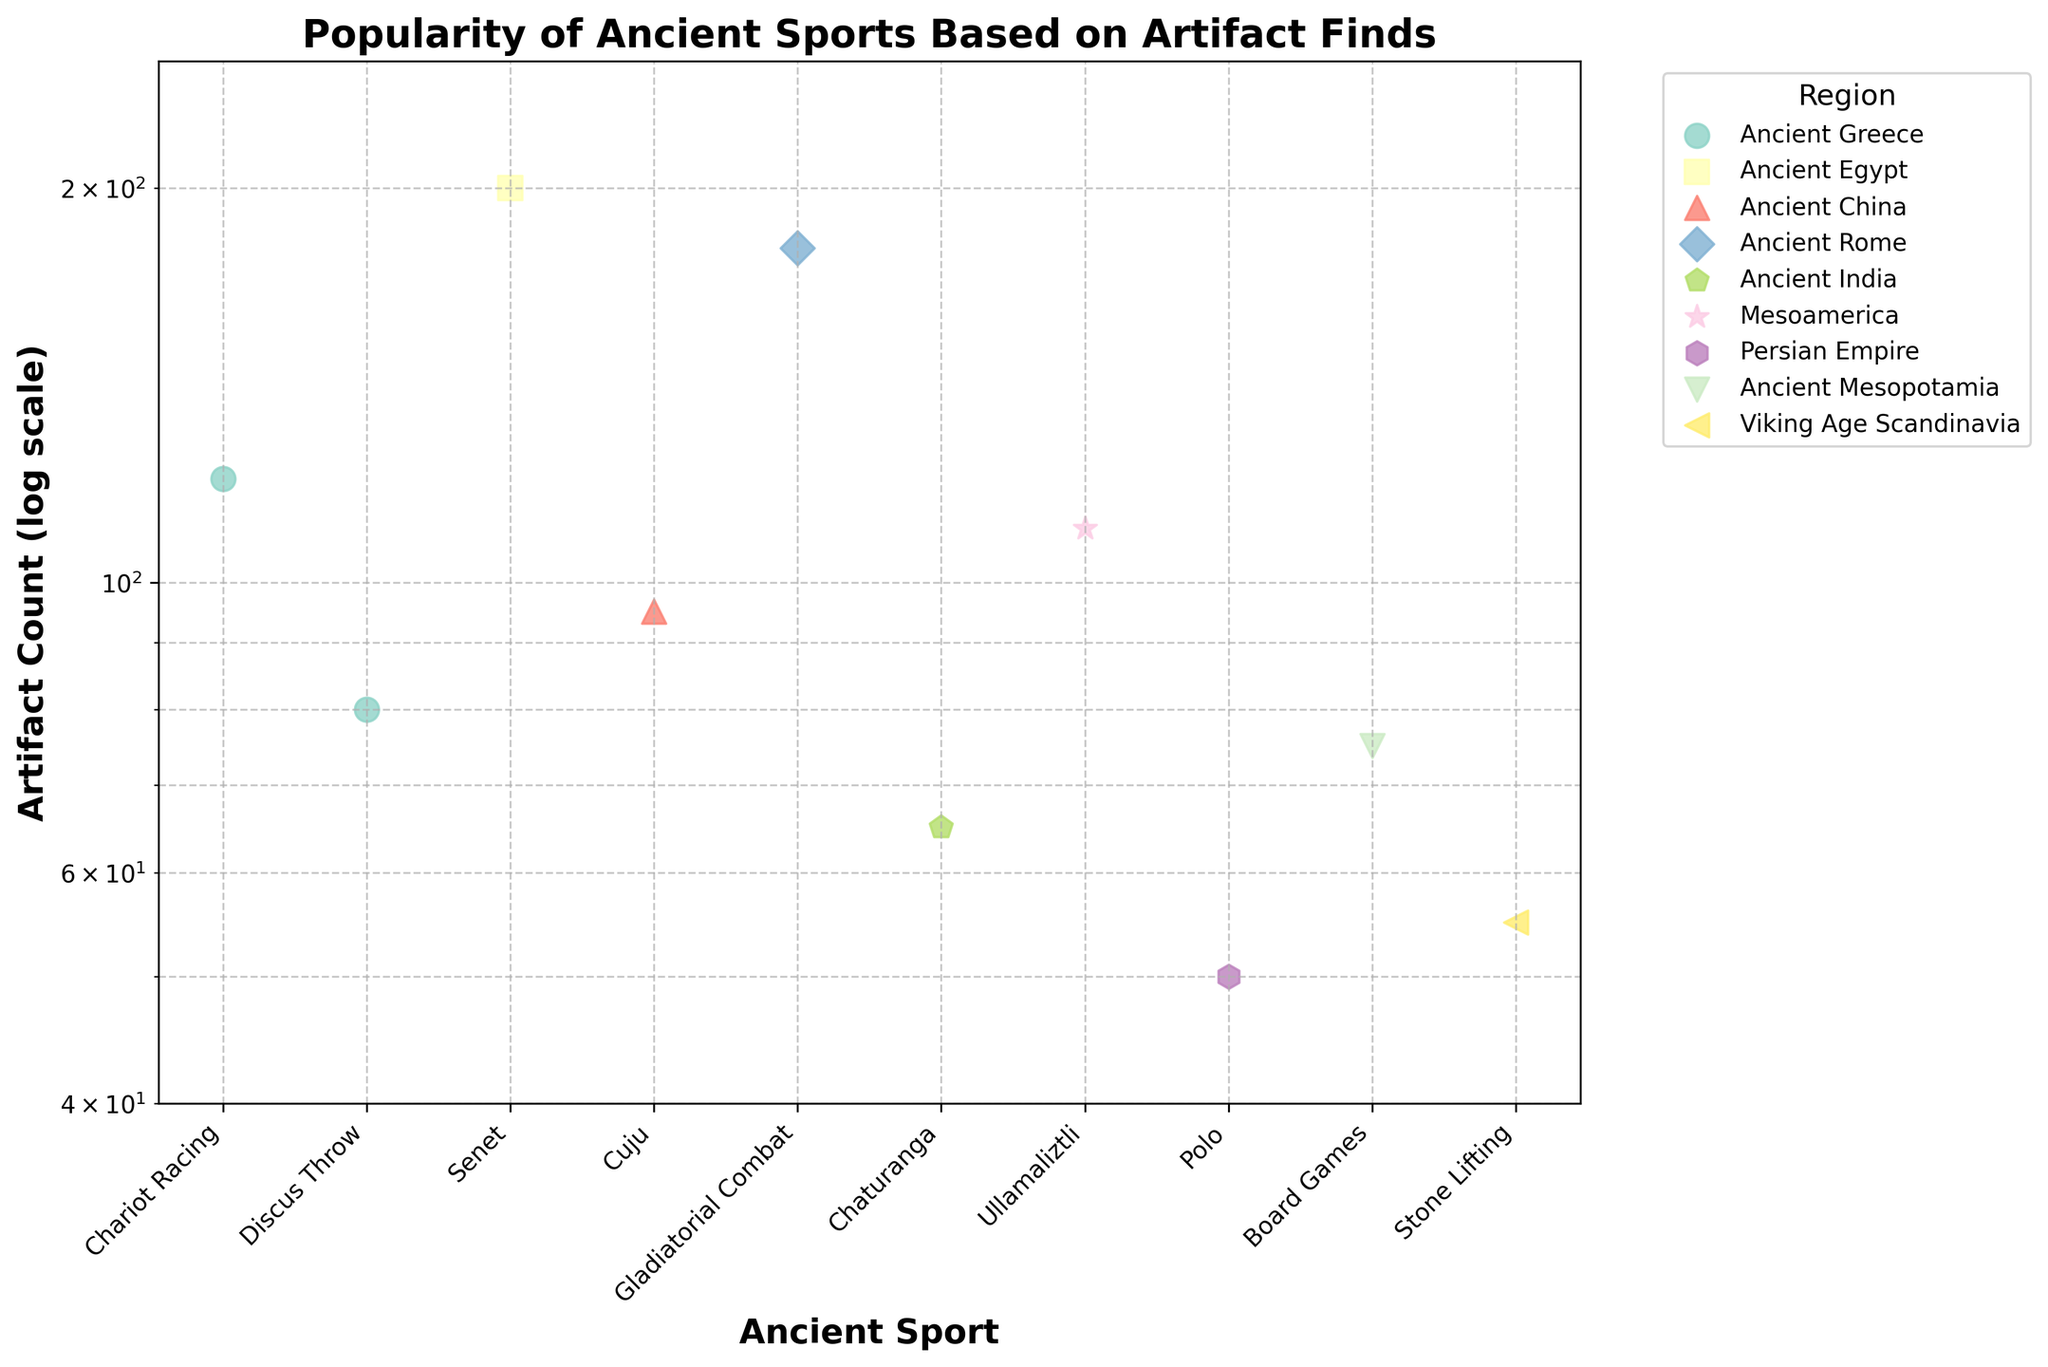What is the title of the figure? The title of the figure is prominently displayed at the top and usually summarizes what the plot is about.
Answer: Popularity of Ancient Sports Based on Artifact Finds Which region has the highest artifact count for an ancient sport? Look at the points with the highest values on the y-axis across all regions, the region with the highest y-value represents the highest artifact count. The point for 'Senet' in 'Ancient Egypt' is the highest.
Answer: Ancient Egypt What is the artifact count for Chariot Racing in Ancient Greece? Find the marker corresponding to Chariot Racing in Ancient Greece and read the y-value associated with it.
Answer: 120 Which ancient sport in Ancient India has the lowest artifact count, and what is it? For Ancient India, find the points on the plot, and identify the one with the lowest y-value. Only one sport, Chaturanga, is displayed for Ancient India.
Answer: Chaturanga with 65 artifacts Compare the artifact counts between Gladiatorial Combat in Ancient Rome and Ullamaliztli in Mesoamerica. Which has more artifact finds? Locate both on the y-axis and compare the y-values. The artifact count for Gladiatorial Combat in Ancient Rome is 180 whereas for Ullamaliztli in Mesoamerica it is 110.
Answer: Gladiatorial Combat in Ancient Rome What is the minimum artifact count displayed in the plot? Look at the lowest value on the y-axis within the plotted range. The lowest point corresponds to Polo in the Persian Empire.
Answer: 50 How many ancient sports have artifact counts greater than 100? Count the number of points above the y-value of 100. These are Chariot Racing (Ancient Greece), Senet (Ancient Egypt), Gladiatorial Combat (Ancient Rome), and Ullamaliztli (Mesoamerica).
Answer: Four Determine the approximate range of artifact counts for ancient sports in Ancient Greece. Identify the points for Ancient Greece and determine their y-values to find the range. Chariot Racing with 120 and Discus Throw with 80 give a range of 80 to 120.
Answer: 80 to 120 Which region has the most distinct ancient sports displayed in the plot? Count the number of distinct points (ancient sports) for each region by observing the legend or colors. Regions with two distinct points are Ancient Greece.
Answer: Ancient Greece Why is the y-axis on a log scale, and what advantage does this provide in interpreting the data? A log scale allows for a better visualization of data spanning several orders of magnitude by reducing wide-ranging values to a more manageable, compressed scale. This makes it easier to compare data points that vary greatly in magnitude.
Answer: Easier to compare wide-ranging values 